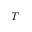Convert formula to latex. <formula><loc_0><loc_0><loc_500><loc_500>T</formula> 